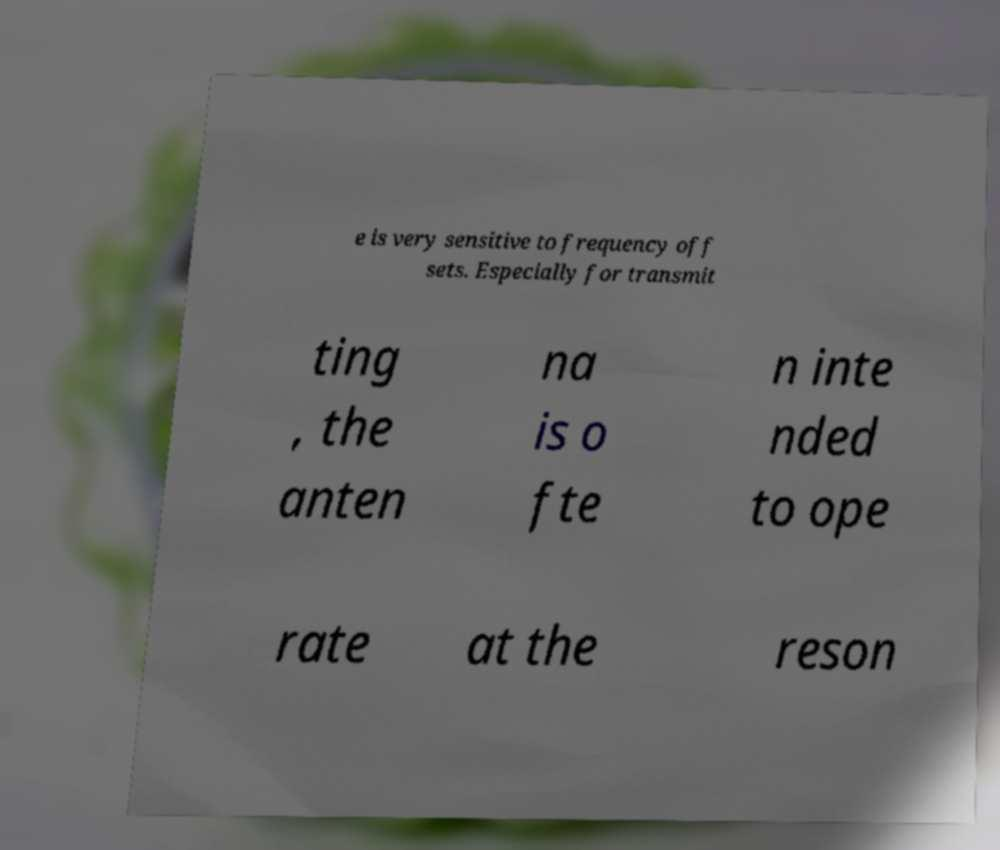Could you assist in decoding the text presented in this image and type it out clearly? e is very sensitive to frequency off sets. Especially for transmit ting , the anten na is o fte n inte nded to ope rate at the reson 